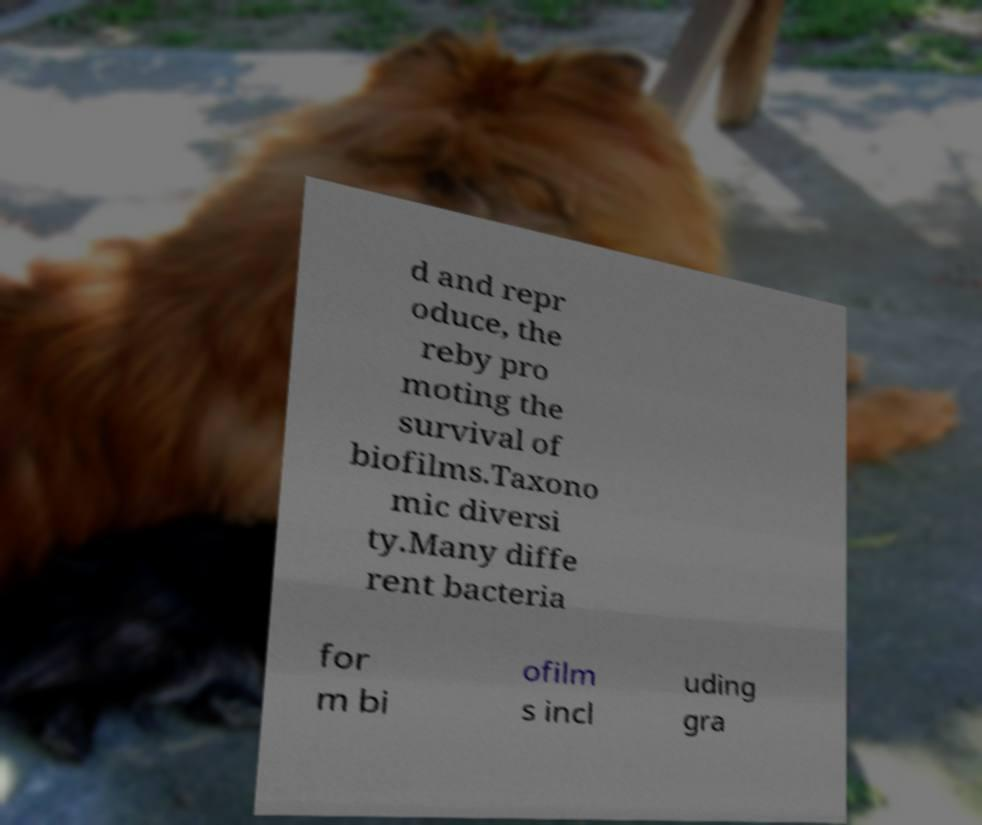Please identify and transcribe the text found in this image. d and repr oduce, the reby pro moting the survival of biofilms.Taxono mic diversi ty.Many diffe rent bacteria for m bi ofilm s incl uding gra 